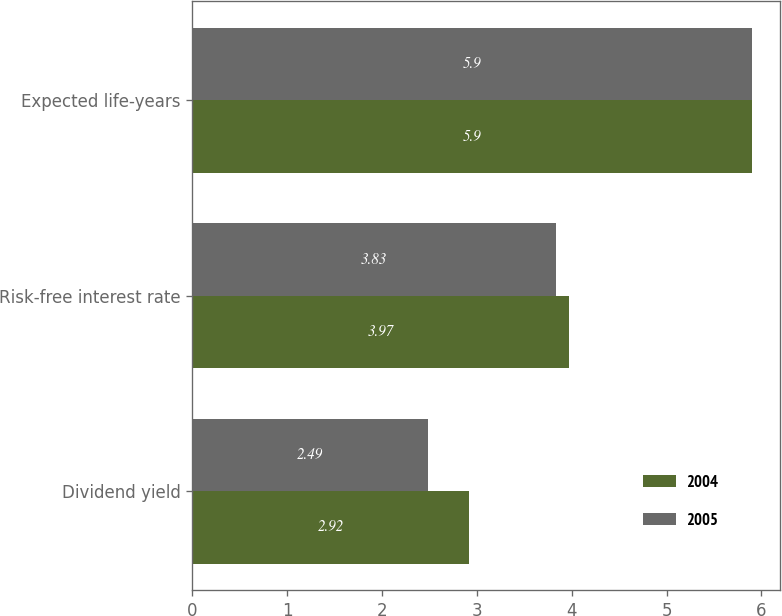Convert chart to OTSL. <chart><loc_0><loc_0><loc_500><loc_500><stacked_bar_chart><ecel><fcel>Dividend yield<fcel>Risk-free interest rate<fcel>Expected life-years<nl><fcel>2004<fcel>2.92<fcel>3.97<fcel>5.9<nl><fcel>2005<fcel>2.49<fcel>3.83<fcel>5.9<nl></chart> 